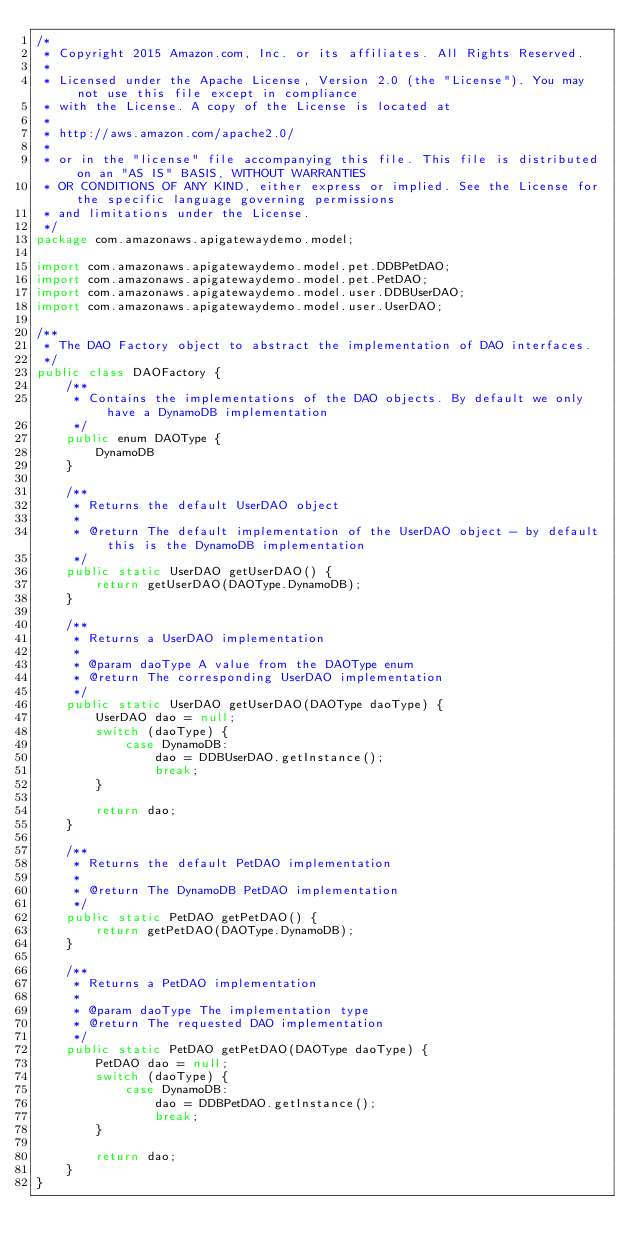<code> <loc_0><loc_0><loc_500><loc_500><_Java_>/*
 * Copyright 2015 Amazon.com, Inc. or its affiliates. All Rights Reserved.
 *
 * Licensed under the Apache License, Version 2.0 (the "License"). You may not use this file except in compliance
 * with the License. A copy of the License is located at
 *
 * http://aws.amazon.com/apache2.0/
 *
 * or in the "license" file accompanying this file. This file is distributed on an "AS IS" BASIS, WITHOUT WARRANTIES
 * OR CONDITIONS OF ANY KIND, either express or implied. See the License for the specific language governing permissions
 * and limitations under the License.
 */
package com.amazonaws.apigatewaydemo.model;

import com.amazonaws.apigatewaydemo.model.pet.DDBPetDAO;
import com.amazonaws.apigatewaydemo.model.pet.PetDAO;
import com.amazonaws.apigatewaydemo.model.user.DDBUserDAO;
import com.amazonaws.apigatewaydemo.model.user.UserDAO;

/**
 * The DAO Factory object to abstract the implementation of DAO interfaces.
 */
public class DAOFactory {
    /**
     * Contains the implementations of the DAO objects. By default we only have a DynamoDB implementation
     */
    public enum DAOType {
        DynamoDB
    }

    /**
     * Returns the default UserDAO object
     *
     * @return The default implementation of the UserDAO object - by default this is the DynamoDB implementation
     */
    public static UserDAO getUserDAO() {
        return getUserDAO(DAOType.DynamoDB);
    }

    /**
     * Returns a UserDAO implementation
     *
     * @param daoType A value from the DAOType enum
     * @return The corresponding UserDAO implementation
     */
    public static UserDAO getUserDAO(DAOType daoType) {
        UserDAO dao = null;
        switch (daoType) {
            case DynamoDB:
                dao = DDBUserDAO.getInstance();
                break;
        }

        return dao;
    }

    /**
     * Returns the default PetDAO implementation
     *
     * @return The DynamoDB PetDAO implementation
     */
    public static PetDAO getPetDAO() {
        return getPetDAO(DAOType.DynamoDB);
    }

    /**
     * Returns a PetDAO implementation
     *
     * @param daoType The implementation type
     * @return The requested DAO implementation
     */
    public static PetDAO getPetDAO(DAOType daoType) {
        PetDAO dao = null;
        switch (daoType) {
            case DynamoDB:
                dao = DDBPetDAO.getInstance();
                break;
        }

        return dao;
    }
}
</code> 